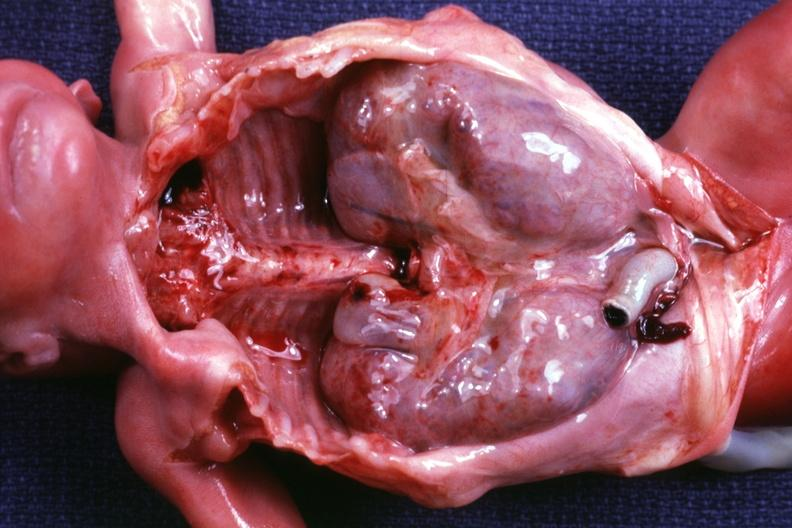does larynx show kidneys in situ with other organs removed dramatic demonstration of size of kidneys?
Answer the question using a single word or phrase. No 